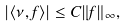<formula> <loc_0><loc_0><loc_500><loc_500>| \langle \nu , f \rangle | \leq C \| f \| _ { \infty } ,</formula> 